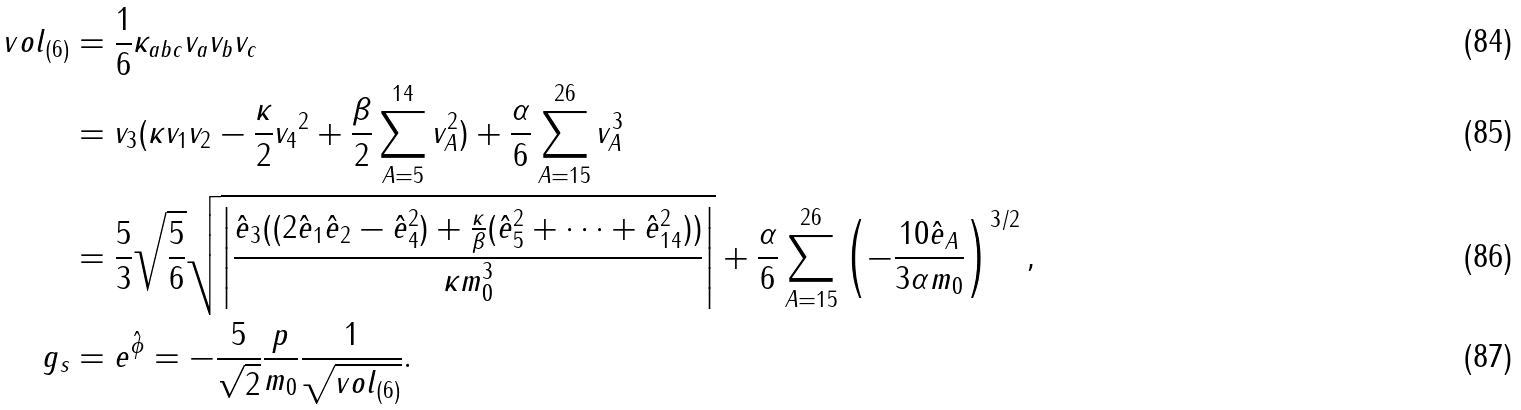<formula> <loc_0><loc_0><loc_500><loc_500>v o l _ { ( 6 ) } & = \frac { 1 } { 6 } \kappa _ { a b c } v _ { a } v _ { b } v _ { c } \\ & = v _ { 3 } ( \kappa v _ { 1 } v _ { 2 } - \frac { \kappa } { 2 } { v _ { 4 } } ^ { 2 } + \frac { \beta } { 2 } \sum _ { A = 5 } ^ { 1 4 } v _ { A } ^ { 2 } ) + \frac { \alpha } { 6 } \sum _ { A = 1 5 } ^ { 2 6 } v _ { A } ^ { 3 } \\ & = \frac { 5 } { 3 } \sqrt { \frac { 5 } { 6 } } \sqrt { \left | \frac { \hat { e } _ { 3 } ( ( 2 \hat { e } _ { 1 } \hat { e } _ { 2 } - \hat { e } _ { 4 } ^ { 2 } ) + \frac { \kappa } { \beta } ( \hat { e } _ { 5 } ^ { 2 } + \dots + \hat { e } _ { 1 4 } ^ { 2 } ) ) } { \kappa m _ { 0 } ^ { 3 } } \right | } + \frac { \alpha } { 6 } \sum _ { A = 1 5 } ^ { 2 6 } \left ( - \frac { 1 0 \hat { e } _ { A } } { 3 \alpha m _ { 0 } } \right ) ^ { 3 / 2 } , \\ g _ { s } & = e ^ { \hat { \phi } } = - \frac { 5 } { \sqrt { 2 } } \frac { p } { m _ { 0 } } \frac { 1 } { \sqrt { v o l _ { ( 6 ) } } } .</formula> 